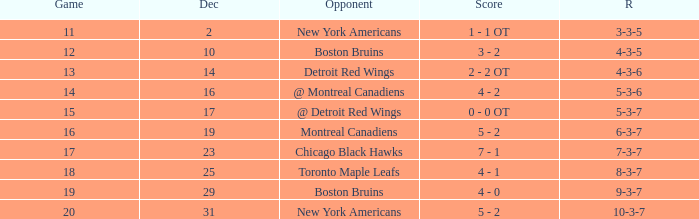Which Score has a December smaller than 14, and a Game of 12? 3 - 2. 